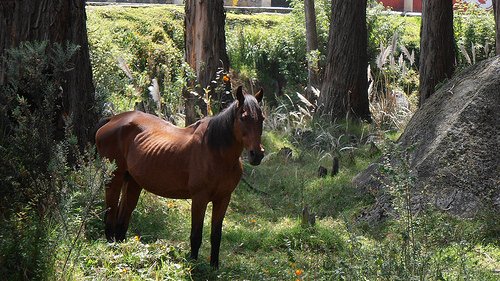<image>
Can you confirm if the horse is behind the tree? No. The horse is not behind the tree. From this viewpoint, the horse appears to be positioned elsewhere in the scene. Where is the horse in relation to the rock? Is it next to the rock? Yes. The horse is positioned adjacent to the rock, located nearby in the same general area. 